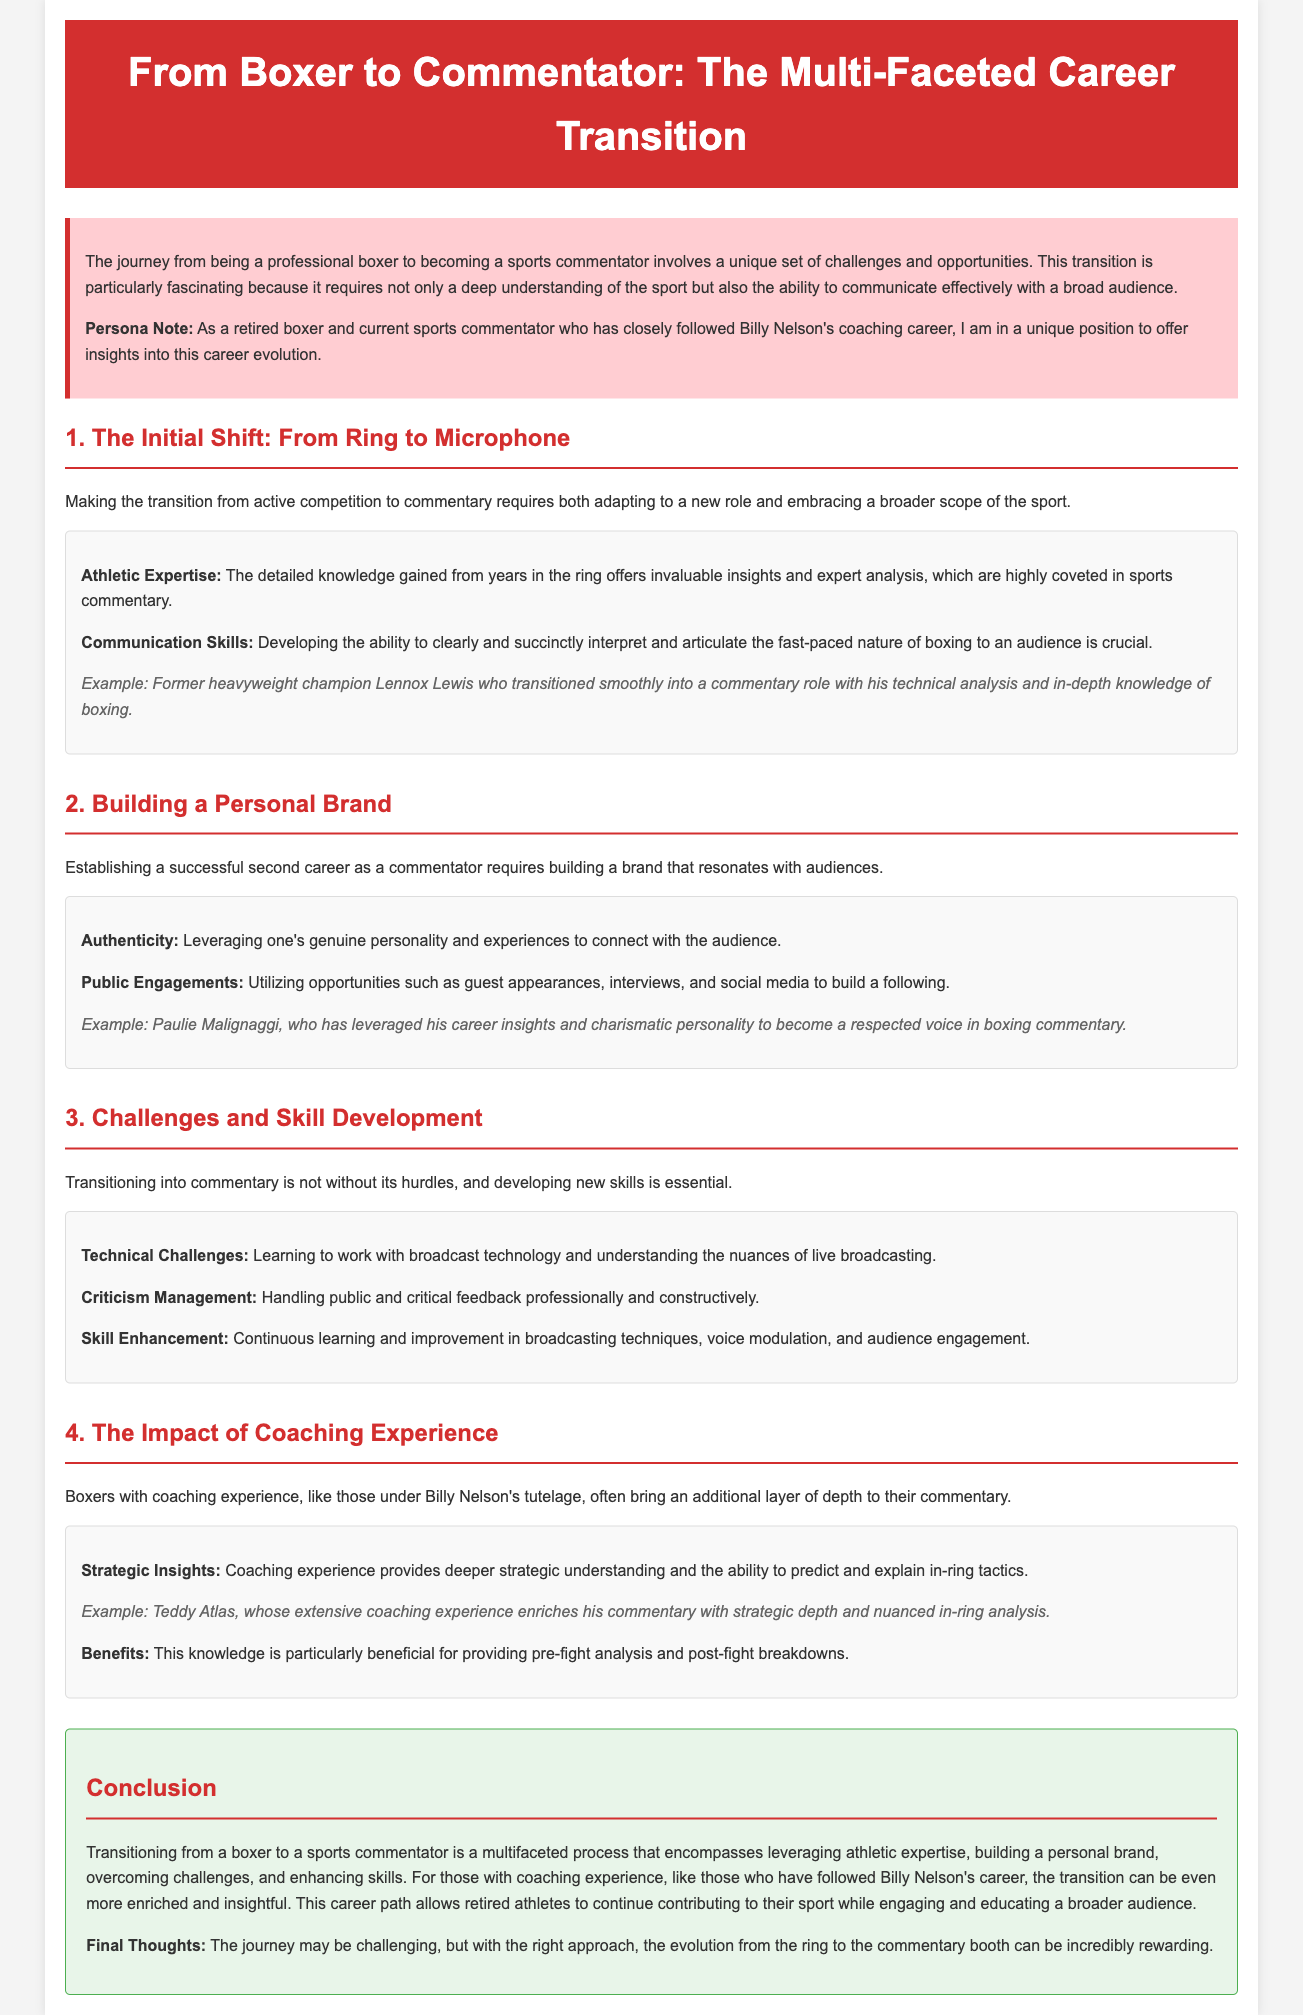what is the title of the whitepaper? The title is stated prominently at the top of the document.
Answer: From Boxer to Commentator: The Multi-Faceted Career Transition who is mentioned as an example of a successful transition to commentary? The document provides specific examples in the key points sections.
Answer: Lennox Lewis which section discusses building a personal brand? The title of the section clearly indicates the focus of the content.
Answer: Building a Personal Brand what is one of the challenges faced in the transition to commentary? The document lists various challenges within the relevant section.
Answer: Technical Challenges what impact does coaching experience have on commentary? The section titles and key points specifically address this topic.
Answer: Strategic Insights how does the document categorize the types of questions discussed? The introduction outlines various themes addressed throughout the paper.
Answer: Information Retrieval, Reasoning, Document Type-specific questions who is noted for having a charismatic personality in commentary? The example provided highlights a specific individual's approach in building a brand.
Answer: Paulie Malignaggi what is one benefit of having coaching experience for boxers transitioning to commentary? The document lists advantages in the section discussing coaching experience.
Answer: Deeper strategic understanding 